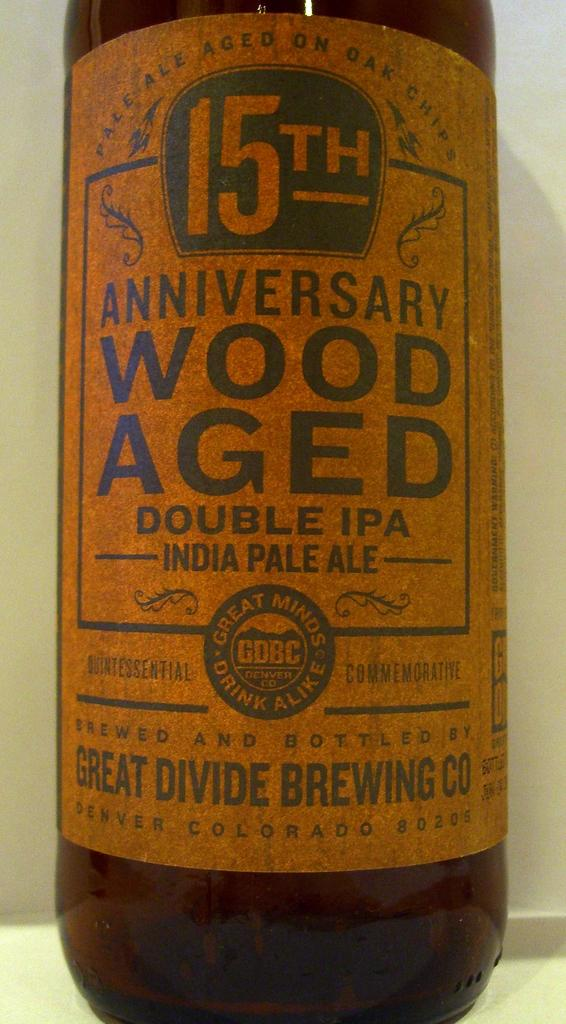What object can be seen in the image? There is a bottle in the image. Where is the bottle located in the image? The bottle is placed on a surface. How many passengers are visible in the image? There are no passengers present in the image; it only features a bottle placed on a surface. What type of pickle is being served with the bottle in the image? There is no pickle present in the image; it only features a bottle placed on a surface. 